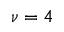<formula> <loc_0><loc_0><loc_500><loc_500>\nu = 4</formula> 